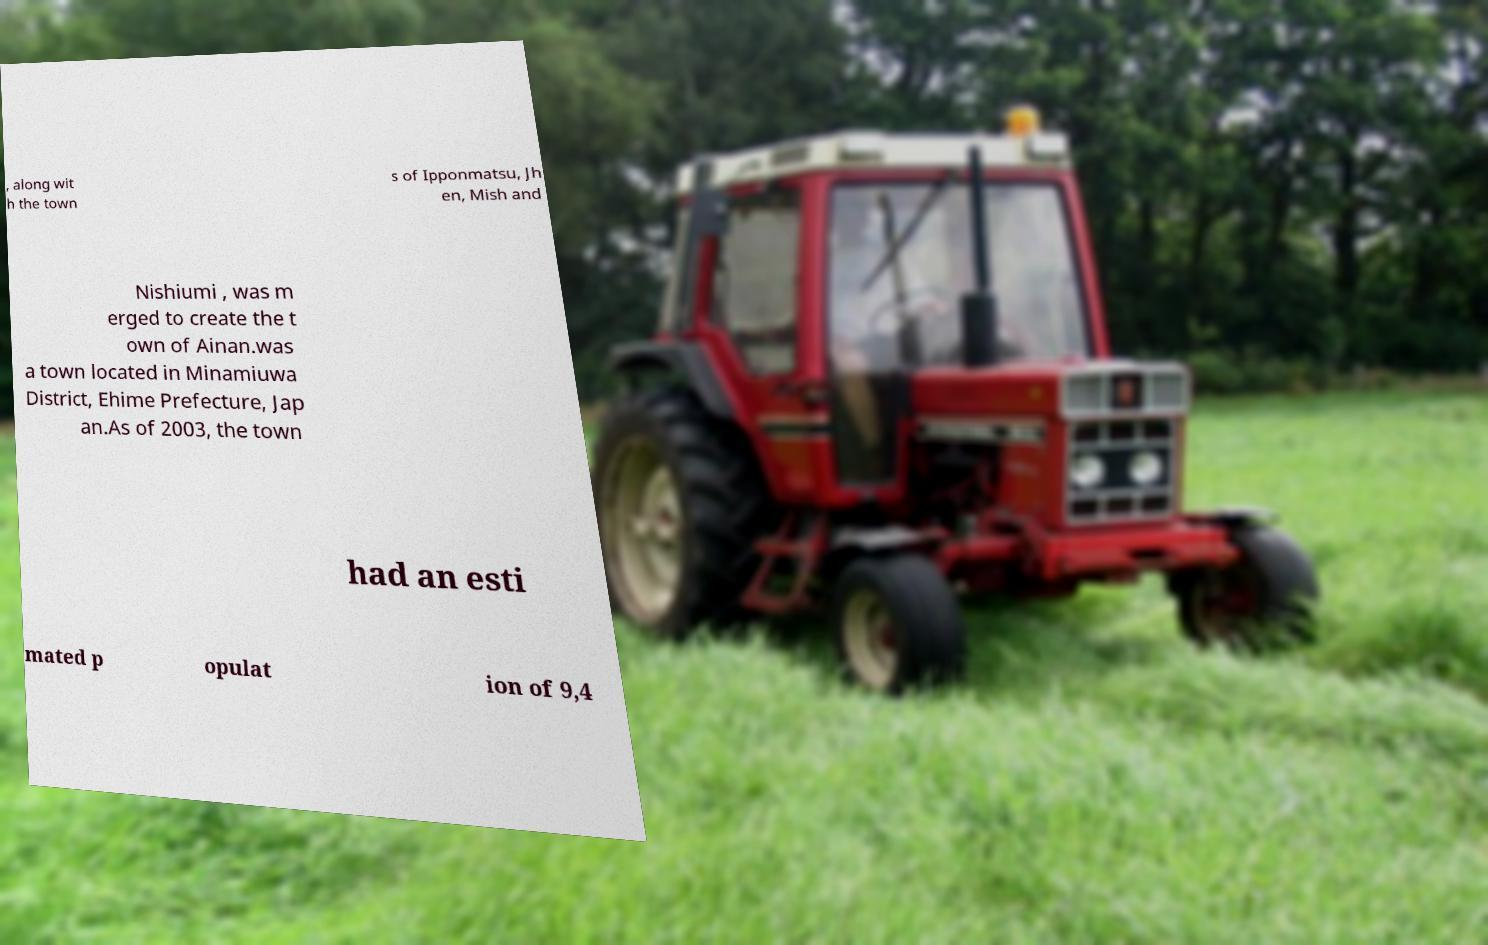For documentation purposes, I need the text within this image transcribed. Could you provide that? , along wit h the town s of Ipponmatsu, Jh en, Mish and Nishiumi , was m erged to create the t own of Ainan.was a town located in Minamiuwa District, Ehime Prefecture, Jap an.As of 2003, the town had an esti mated p opulat ion of 9,4 